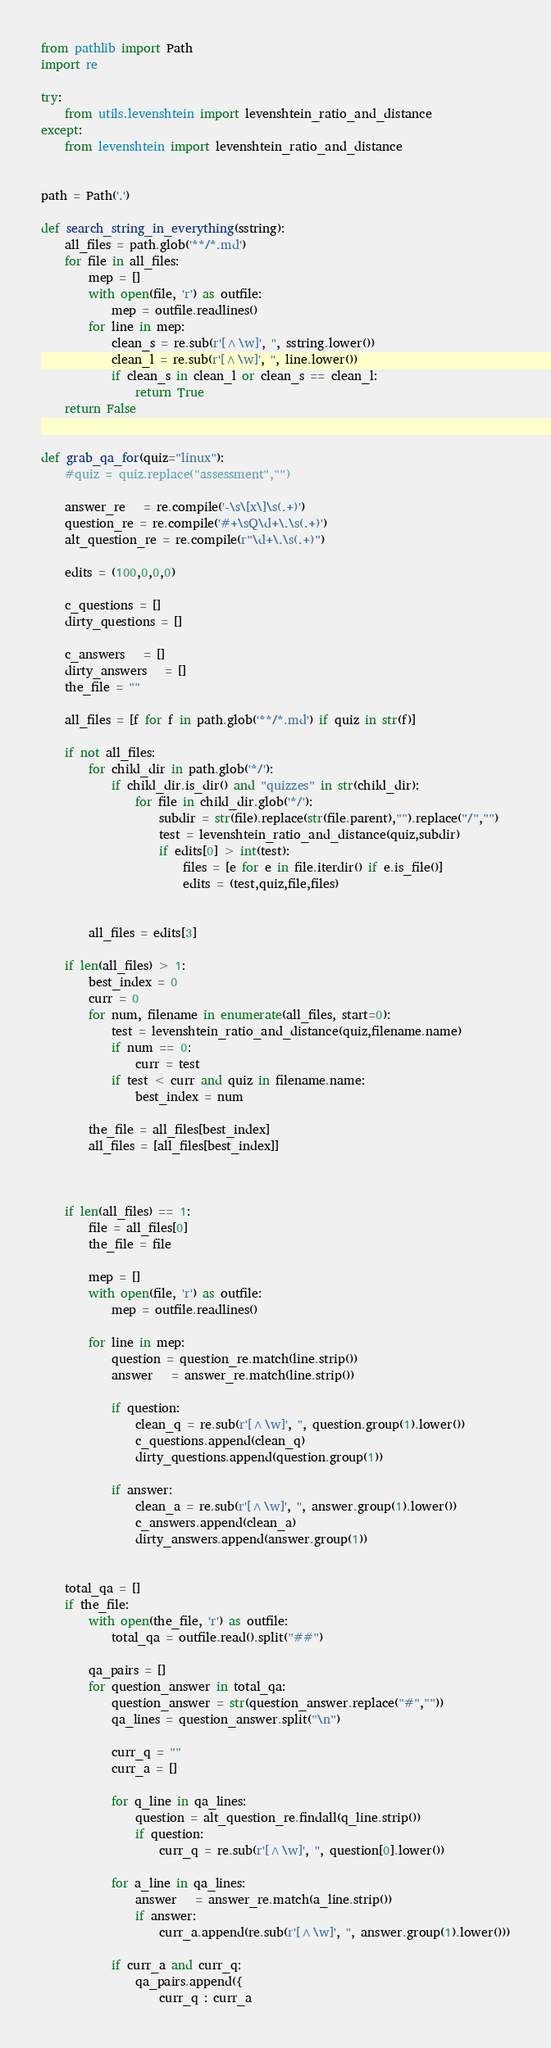<code> <loc_0><loc_0><loc_500><loc_500><_Python_>from pathlib import Path
import re

try:
    from utils.levenshtein import levenshtein_ratio_and_distance
except:
    from levenshtein import levenshtein_ratio_and_distance
 

path = Path('.')   

def search_string_in_everything(sstring):
    all_files = path.glob('**/*.md')
    for file in all_files:
        mep = []
        with open(file, 'r') as outfile:
            mep = outfile.readlines()
        for line in mep:
            clean_s = re.sub(r'[^\w]', '', sstring.lower())
            clean_l = re.sub(r'[^\w]', '', line.lower())
            if clean_s in clean_l or clean_s == clean_l:
                return True 
    return False 
             

def grab_qa_for(quiz="linux"): 
    #quiz = quiz.replace("assessment","")
    
    answer_re   = re.compile('-\s\[x\]\s(.+)')
    question_re = re.compile('#+\sQ\d+\.\s(.+)')
    alt_question_re = re.compile(r"\d+\.\s(.+)")

    edits = (100,0,0,0)
    
    c_questions = []
    dirty_questions = []
    
    c_answers   = []
    dirty_answers   = []
    the_file = ""
    
    all_files = [f for f in path.glob('**/*.md') if quiz in str(f)]
    
    if not all_files:
        for child_dir in path.glob('*/'):
            if child_dir.is_dir() and "quizzes" in str(child_dir):
                for file in child_dir.glob('*/'):
                    subdir = str(file).replace(str(file.parent),"").replace("/","")
                    test = levenshtein_ratio_and_distance(quiz,subdir)
                    if edits[0] > int(test):
                        files = [e for e in file.iterdir() if e.is_file()]
                        edits = (test,quiz,file,files)  
                       

        all_files = edits[3]

    if len(all_files) > 1:
        best_index = 0 
        curr = 0 
        for num, filename in enumerate(all_files, start=0):
            test = levenshtein_ratio_and_distance(quiz,filename.name)
            if num == 0:
                curr = test
            if test < curr and quiz in filename.name:
                best_index = num     
                
        the_file = all_files[best_index]           
        all_files = [all_files[best_index]]
        
           

    if len(all_files) == 1:
        file = all_files[0]
        the_file = file
        
        mep = []
        with open(file, 'r') as outfile:
            mep = outfile.readlines()
            
        for line in mep:
            question = question_re.match(line.strip())
            answer   = answer_re.match(line.strip())
        
            if question:
                clean_q = re.sub(r'[^\w]', '', question.group(1).lower())
                c_questions.append(clean_q)
                dirty_questions.append(question.group(1))
                
            if answer:
                clean_a = re.sub(r'[^\w]', '', answer.group(1).lower())
                c_answers.append(clean_a)
                dirty_answers.append(answer.group(1))
                
                
    total_qa = []        
    if the_file:
        with open(the_file, 'r') as outfile:
            total_qa = outfile.read().split("##")
                
        qa_pairs = []
        for question_answer in total_qa:
            question_answer = str(question_answer.replace("#",""))
            qa_lines = question_answer.split("\n")
            
            curr_q = ""
            curr_a = []
            
            for q_line in qa_lines:
                question = alt_question_re.findall(q_line.strip())
                if question:
                    curr_q = re.sub(r'[^\w]', '', question[0].lower())
                    
            for a_line in qa_lines:            
                answer   = answer_re.match(a_line.strip())
                if answer:
                    curr_a.append(re.sub(r'[^\w]', '', answer.group(1).lower()))

            if curr_a and curr_q:
                qa_pairs.append({
                    curr_q : curr_a</code> 